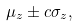Convert formula to latex. <formula><loc_0><loc_0><loc_500><loc_500>\mu _ { z } \pm c \sigma _ { z } ,</formula> 